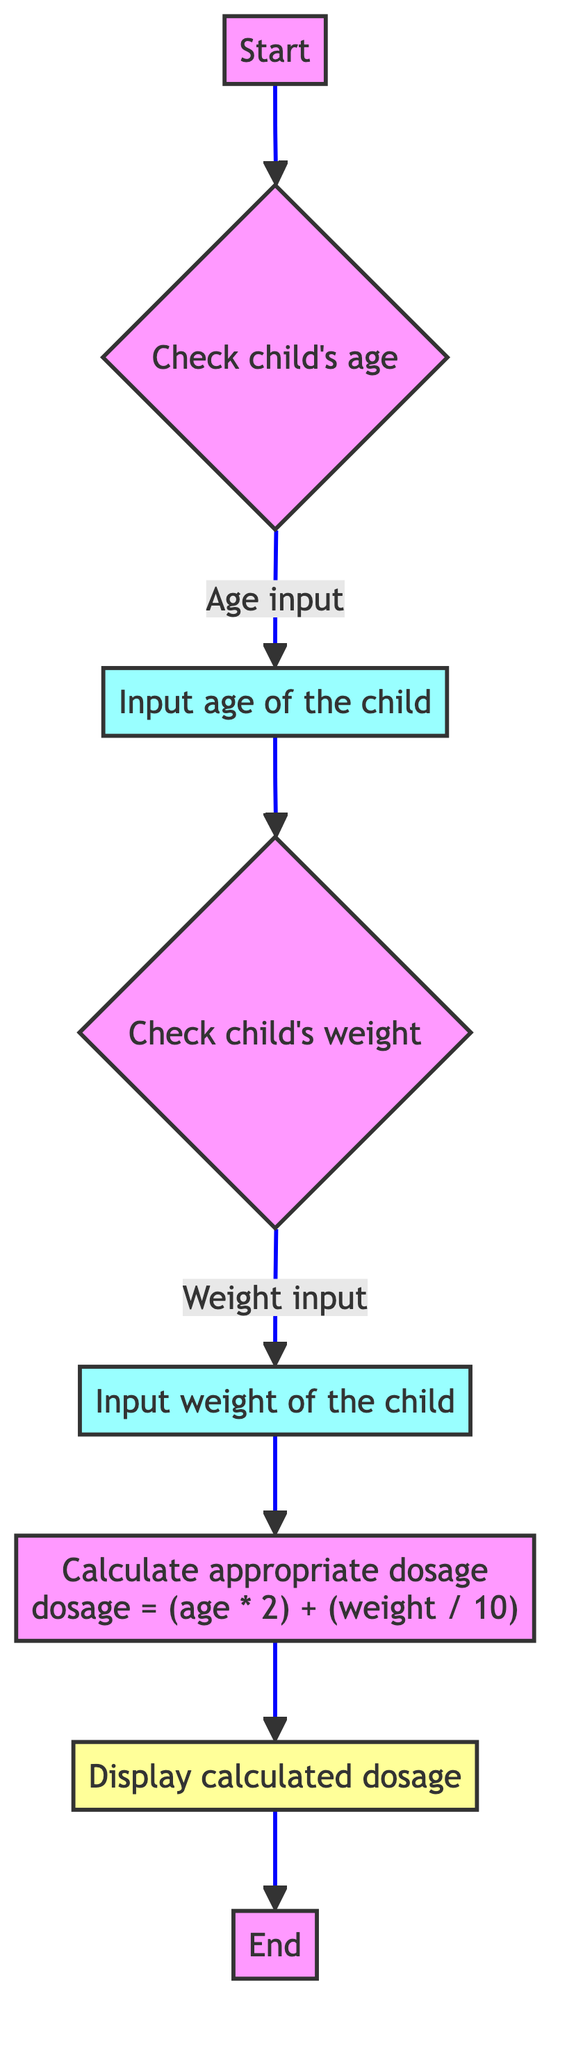What is the first step in the flowchart? The flowchart starts with the 'Start' node, which indicates the beginning of the dosing calculation process.
Answer: Start How many inputs are needed for the dosage calculation? The flowchart shows two input nodes: one for the child's age and one for the child's weight. Therefore, two inputs are needed for the dosage calculation.
Answer: 2 What is the formula used to calculate the dosage? The flowchart presents the formula as 'dosage = (age * 2) + (weight / 10)', which indicates how the dosage is derived based on the child's age and weight.
Answer: dosage = (age * 2) + (weight / 10) What precedes the calculation of the dosage? Before the dosage calculation, the child’s age and weight must be checked and inputted. The flowchart indicates a sequence of inputting the child's age followed by their weight.
Answer: Check child's weight What is the output unit for the calculated dosage? The flowchart specifies that the output for the dosage is measured in milliliters (ml).
Answer: ml How does the flowchart connect the age and weight inputs to dosage calculation? The flowchart shows two branches where, after inputting the age, it leads directly to the weight input before connecting to the dosage calculation node. This means both inputs are essential before calculation.
Answer: Both inputs are essential What happens after displaying the calculated dosage? After the dosage is displayed, the flowchart concludes with the 'End' node, indicating the termination of the process.
Answer: End What type of flowchart is represented here? This is a Program Flowchart, as it outlines a sequential process with calculations involved in determining the dosage.
Answer: Program Flowchart What follows the input of the child's age? Following the input of the child's age, the flowchart proceeds to check and input the child's weight next.
Answer: Check child's weight 